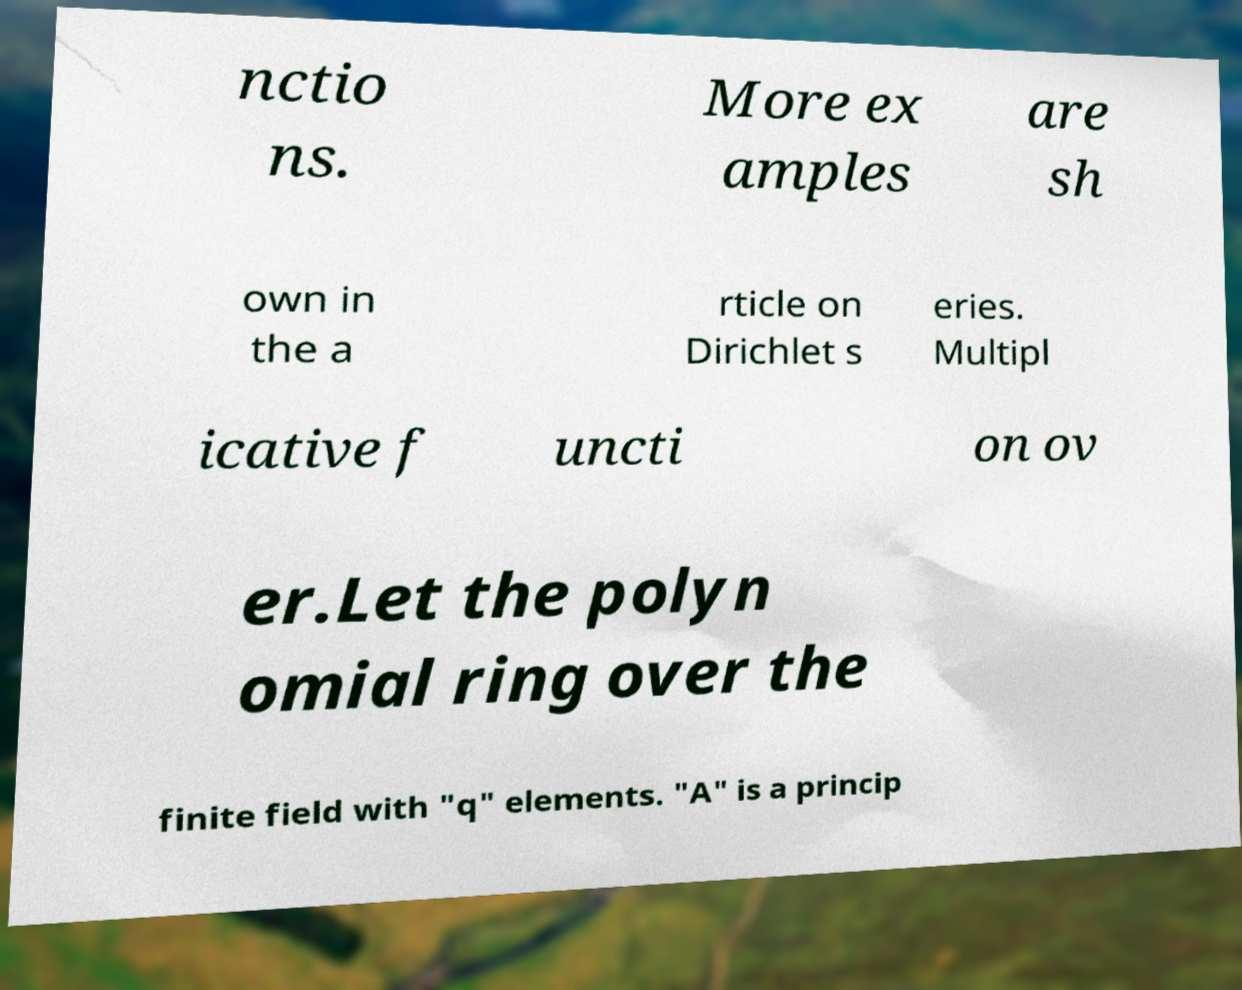Could you extract and type out the text from this image? nctio ns. More ex amples are sh own in the a rticle on Dirichlet s eries. Multipl icative f uncti on ov er.Let the polyn omial ring over the finite field with "q" elements. "A" is a princip 